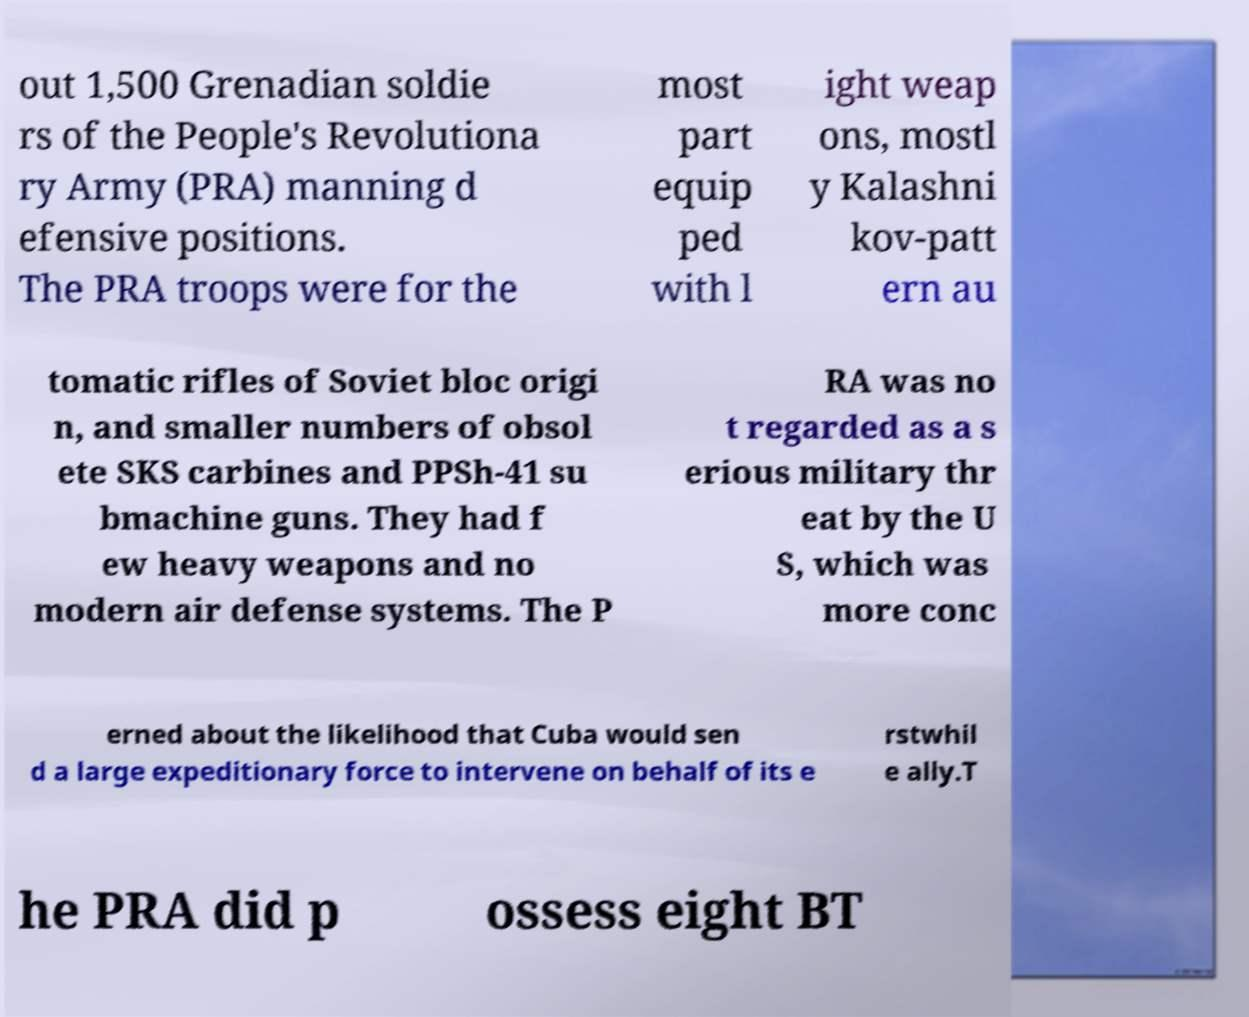Please identify and transcribe the text found in this image. out 1,500 Grenadian soldie rs of the People's Revolutiona ry Army (PRA) manning d efensive positions. The PRA troops were for the most part equip ped with l ight weap ons, mostl y Kalashni kov-patt ern au tomatic rifles of Soviet bloc origi n, and smaller numbers of obsol ete SKS carbines and PPSh-41 su bmachine guns. They had f ew heavy weapons and no modern air defense systems. The P RA was no t regarded as a s erious military thr eat by the U S, which was more conc erned about the likelihood that Cuba would sen d a large expeditionary force to intervene on behalf of its e rstwhil e ally.T he PRA did p ossess eight BT 